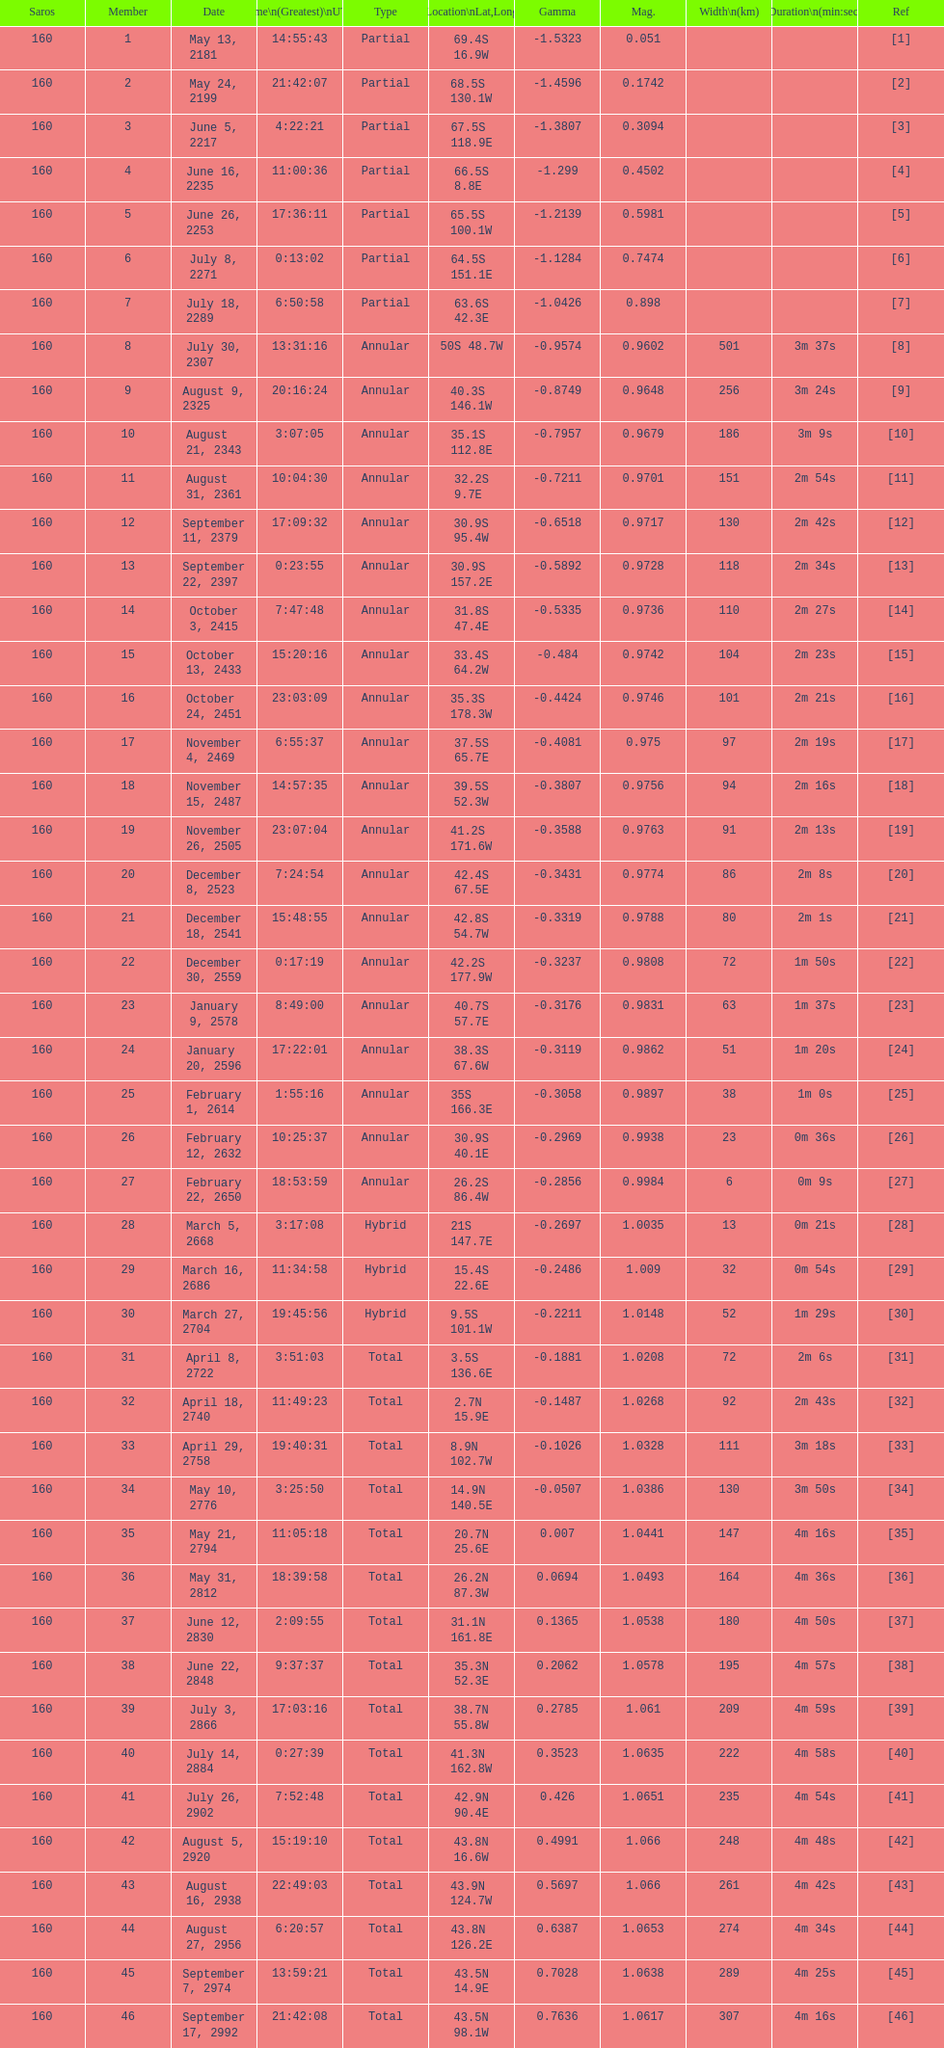I'm looking to parse the entire table for insights. Could you assist me with that? {'header': ['Saros', 'Member', 'Date', 'Time\\n(Greatest)\\nUTC', 'Type', 'Location\\nLat,Long', 'Gamma', 'Mag.', 'Width\\n(km)', 'Duration\\n(min:sec)', 'Ref'], 'rows': [['160', '1', 'May 13, 2181', '14:55:43', 'Partial', '69.4S 16.9W', '-1.5323', '0.051', '', '', '[1]'], ['160', '2', 'May 24, 2199', '21:42:07', 'Partial', '68.5S 130.1W', '-1.4596', '0.1742', '', '', '[2]'], ['160', '3', 'June 5, 2217', '4:22:21', 'Partial', '67.5S 118.9E', '-1.3807', '0.3094', '', '', '[3]'], ['160', '4', 'June 16, 2235', '11:00:36', 'Partial', '66.5S 8.8E', '-1.299', '0.4502', '', '', '[4]'], ['160', '5', 'June 26, 2253', '17:36:11', 'Partial', '65.5S 100.1W', '-1.2139', '0.5981', '', '', '[5]'], ['160', '6', 'July 8, 2271', '0:13:02', 'Partial', '64.5S 151.1E', '-1.1284', '0.7474', '', '', '[6]'], ['160', '7', 'July 18, 2289', '6:50:58', 'Partial', '63.6S 42.3E', '-1.0426', '0.898', '', '', '[7]'], ['160', '8', 'July 30, 2307', '13:31:16', 'Annular', '50S 48.7W', '-0.9574', '0.9602', '501', '3m 37s', '[8]'], ['160', '9', 'August 9, 2325', '20:16:24', 'Annular', '40.3S 146.1W', '-0.8749', '0.9648', '256', '3m 24s', '[9]'], ['160', '10', 'August 21, 2343', '3:07:05', 'Annular', '35.1S 112.8E', '-0.7957', '0.9679', '186', '3m 9s', '[10]'], ['160', '11', 'August 31, 2361', '10:04:30', 'Annular', '32.2S 9.7E', '-0.7211', '0.9701', '151', '2m 54s', '[11]'], ['160', '12', 'September 11, 2379', '17:09:32', 'Annular', '30.9S 95.4W', '-0.6518', '0.9717', '130', '2m 42s', '[12]'], ['160', '13', 'September 22, 2397', '0:23:55', 'Annular', '30.9S 157.2E', '-0.5892', '0.9728', '118', '2m 34s', '[13]'], ['160', '14', 'October 3, 2415', '7:47:48', 'Annular', '31.8S 47.4E', '-0.5335', '0.9736', '110', '2m 27s', '[14]'], ['160', '15', 'October 13, 2433', '15:20:16', 'Annular', '33.4S 64.2W', '-0.484', '0.9742', '104', '2m 23s', '[15]'], ['160', '16', 'October 24, 2451', '23:03:09', 'Annular', '35.3S 178.3W', '-0.4424', '0.9746', '101', '2m 21s', '[16]'], ['160', '17', 'November 4, 2469', '6:55:37', 'Annular', '37.5S 65.7E', '-0.4081', '0.975', '97', '2m 19s', '[17]'], ['160', '18', 'November 15, 2487', '14:57:35', 'Annular', '39.5S 52.3W', '-0.3807', '0.9756', '94', '2m 16s', '[18]'], ['160', '19', 'November 26, 2505', '23:07:04', 'Annular', '41.2S 171.6W', '-0.3588', '0.9763', '91', '2m 13s', '[19]'], ['160', '20', 'December 8, 2523', '7:24:54', 'Annular', '42.4S 67.5E', '-0.3431', '0.9774', '86', '2m 8s', '[20]'], ['160', '21', 'December 18, 2541', '15:48:55', 'Annular', '42.8S 54.7W', '-0.3319', '0.9788', '80', '2m 1s', '[21]'], ['160', '22', 'December 30, 2559', '0:17:19', 'Annular', '42.2S 177.9W', '-0.3237', '0.9808', '72', '1m 50s', '[22]'], ['160', '23', 'January 9, 2578', '8:49:00', 'Annular', '40.7S 57.7E', '-0.3176', '0.9831', '63', '1m 37s', '[23]'], ['160', '24', 'January 20, 2596', '17:22:01', 'Annular', '38.3S 67.6W', '-0.3119', '0.9862', '51', '1m 20s', '[24]'], ['160', '25', 'February 1, 2614', '1:55:16', 'Annular', '35S 166.3E', '-0.3058', '0.9897', '38', '1m 0s', '[25]'], ['160', '26', 'February 12, 2632', '10:25:37', 'Annular', '30.9S 40.1E', '-0.2969', '0.9938', '23', '0m 36s', '[26]'], ['160', '27', 'February 22, 2650', '18:53:59', 'Annular', '26.2S 86.4W', '-0.2856', '0.9984', '6', '0m 9s', '[27]'], ['160', '28', 'March 5, 2668', '3:17:08', 'Hybrid', '21S 147.7E', '-0.2697', '1.0035', '13', '0m 21s', '[28]'], ['160', '29', 'March 16, 2686', '11:34:58', 'Hybrid', '15.4S 22.6E', '-0.2486', '1.009', '32', '0m 54s', '[29]'], ['160', '30', 'March 27, 2704', '19:45:56', 'Hybrid', '9.5S 101.1W', '-0.2211', '1.0148', '52', '1m 29s', '[30]'], ['160', '31', 'April 8, 2722', '3:51:03', 'Total', '3.5S 136.6E', '-0.1881', '1.0208', '72', '2m 6s', '[31]'], ['160', '32', 'April 18, 2740', '11:49:23', 'Total', '2.7N 15.9E', '-0.1487', '1.0268', '92', '2m 43s', '[32]'], ['160', '33', 'April 29, 2758', '19:40:31', 'Total', '8.9N 102.7W', '-0.1026', '1.0328', '111', '3m 18s', '[33]'], ['160', '34', 'May 10, 2776', '3:25:50', 'Total', '14.9N 140.5E', '-0.0507', '1.0386', '130', '3m 50s', '[34]'], ['160', '35', 'May 21, 2794', '11:05:18', 'Total', '20.7N 25.6E', '0.007', '1.0441', '147', '4m 16s', '[35]'], ['160', '36', 'May 31, 2812', '18:39:58', 'Total', '26.2N 87.3W', '0.0694', '1.0493', '164', '4m 36s', '[36]'], ['160', '37', 'June 12, 2830', '2:09:55', 'Total', '31.1N 161.8E', '0.1365', '1.0538', '180', '4m 50s', '[37]'], ['160', '38', 'June 22, 2848', '9:37:37', 'Total', '35.3N 52.3E', '0.2062', '1.0578', '195', '4m 57s', '[38]'], ['160', '39', 'July 3, 2866', '17:03:16', 'Total', '38.7N 55.8W', '0.2785', '1.061', '209', '4m 59s', '[39]'], ['160', '40', 'July 14, 2884', '0:27:39', 'Total', '41.3N 162.8W', '0.3523', '1.0635', '222', '4m 58s', '[40]'], ['160', '41', 'July 26, 2902', '7:52:48', 'Total', '42.9N 90.4E', '0.426', '1.0651', '235', '4m 54s', '[41]'], ['160', '42', 'August 5, 2920', '15:19:10', 'Total', '43.8N 16.6W', '0.4991', '1.066', '248', '4m 48s', '[42]'], ['160', '43', 'August 16, 2938', '22:49:03', 'Total', '43.9N 124.7W', '0.5697', '1.066', '261', '4m 42s', '[43]'], ['160', '44', 'August 27, 2956', '6:20:57', 'Total', '43.8N 126.2E', '0.6387', '1.0653', '274', '4m 34s', '[44]'], ['160', '45', 'September 7, 2974', '13:59:21', 'Total', '43.5N 14.9E', '0.7028', '1.0638', '289', '4m 25s', '[45]'], ['160', '46', 'September 17, 2992', '21:42:08', 'Total', '43.5N 98.1W', '0.7636', '1.0617', '307', '4m 16s', '[46]']]} What is the prior instance for the saros on october 3, 2415? 7:47:48. 